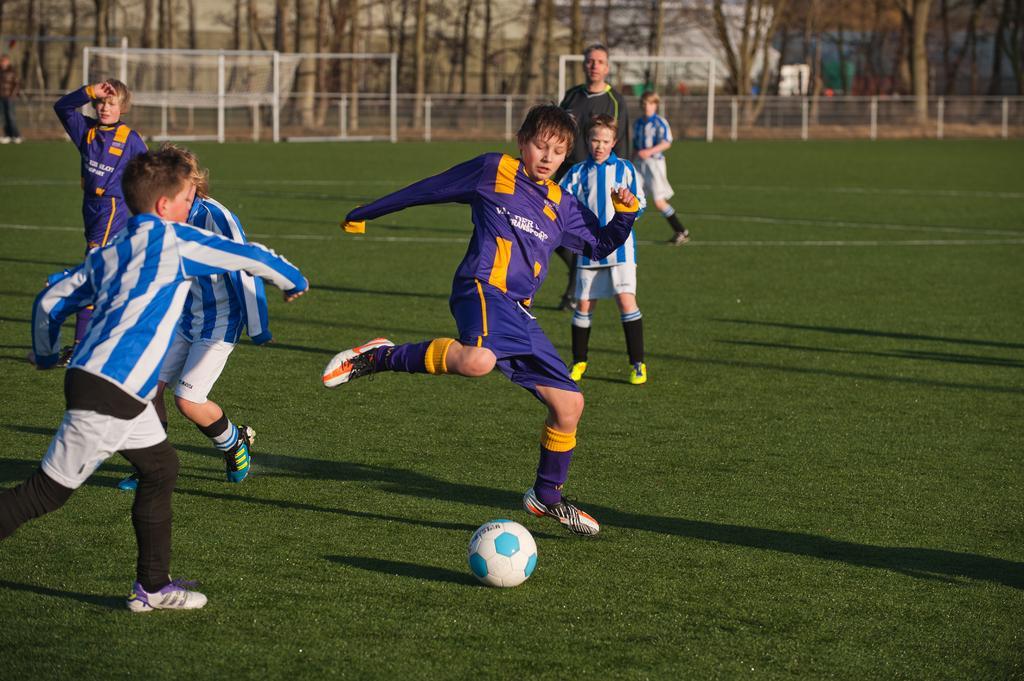Please provide a concise description of this image. In this image there are persons playing a football match. There is grass on the ground. In the background there are nets and there is a fence and there are trees. 